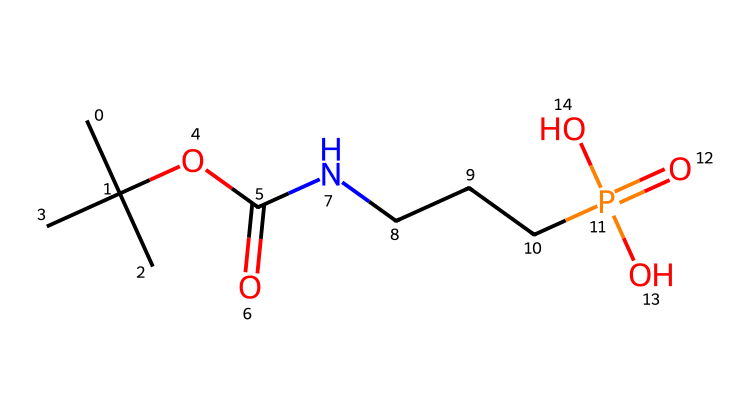how many carbon atoms are present in the chemical? By examining the SMILES representation, we count the carbon atoms. The representation indicates three methyl groups (CC(C)(C)) and one more carbon in the carbonyl (C(=O)). Adding these gives us a total of four carbon atoms.
Answer: four what is the functional group of this molecule? The chemical structure contains an ester group (indicated by OC(=O)) and an amine group (NCCC). This dual presence indicates that the functional groups are both ester and amine.
Answer: ester, amine how many oxygen atoms are in the chemical? Analyzing the SMILES, there are four oxygen atoms: one in the ester group (C(=O)), one in the polyphosphate part ([P](=O)(O)O), and two in the remaining parts of the molecule. Counting these yields a total of four.
Answer: four what type of chemical interaction is likely due to the phosphorous atom? The presence of the phosphorus atom in the chemical structure suggests that it plays a role in ionic interactions or the formation of phosphates, which are known for their capacity to form strong bonds with other elements in fibers.
Answer: ionic interactions why are fire-resistant properties expected in this molecule? The molecule contains both phosphorus and nitrogen, which are elements known to influence flame-retardant properties. Phosphorus can form char layers when exposed to heat, while nitrogen can dilute flammable gases. This combination is effective for fire resistance.
Answer: flame-retardant properties how does the backbone arrangement affect the tensile strength of fibers? The structure of this molecule suggests a branched arrangement with multiple functional groups. This branched nature increases the intermolecular forces that contribute to the tensile strength of the fibers, making them more durable and resistant to breaking under tension.
Answer: increases tensile strength 